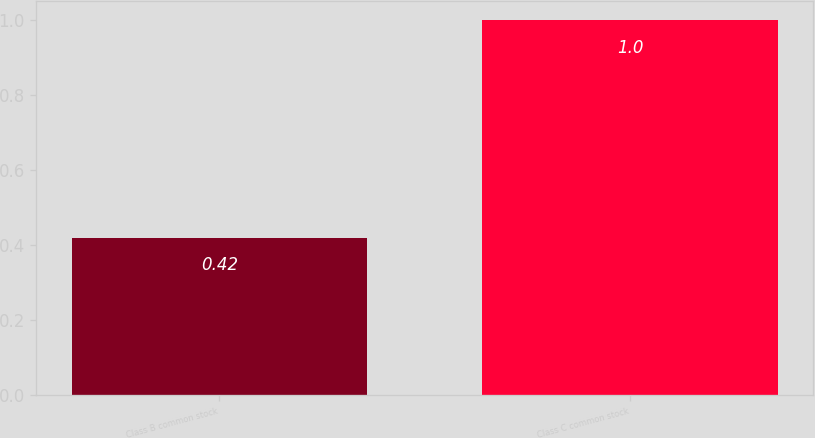Convert chart to OTSL. <chart><loc_0><loc_0><loc_500><loc_500><bar_chart><fcel>Class B common stock<fcel>Class C common stock<nl><fcel>0.42<fcel>1<nl></chart> 